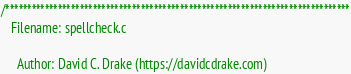Convert code to text. <code><loc_0><loc_0><loc_500><loc_500><_C_>/*******************************************************************************
   Filename: spellcheck.c

     Author: David C. Drake (https://davidcdrake.com)
</code> 